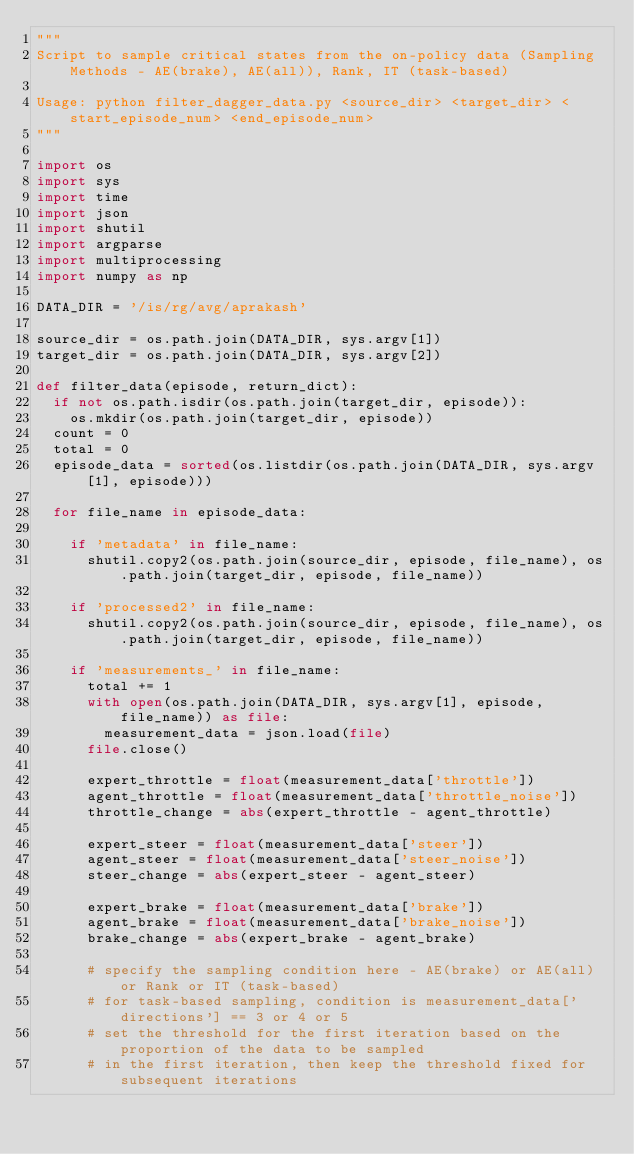<code> <loc_0><loc_0><loc_500><loc_500><_Python_>"""
Script to sample critical states from the on-policy data (Sampling Methods - AE(brake), AE(all)), Rank, IT (task-based)

Usage: python filter_dagger_data.py <source_dir> <target_dir> <start_episode_num> <end_episode_num>
"""

import os
import sys
import time
import json
import shutil
import argparse
import multiprocessing
import numpy as np

DATA_DIR = '/is/rg/avg/aprakash'

source_dir = os.path.join(DATA_DIR, sys.argv[1])
target_dir = os.path.join(DATA_DIR, sys.argv[2])

def filter_data(episode, return_dict):
	if not os.path.isdir(os.path.join(target_dir, episode)):
		os.mkdir(os.path.join(target_dir, episode))
	count = 0
	total = 0
	episode_data = sorted(os.listdir(os.path.join(DATA_DIR, sys.argv[1], episode)))
			
	for file_name in episode_data:
		
		if 'metadata' in file_name:
			shutil.copy2(os.path.join(source_dir, episode, file_name), os.path.join(target_dir, episode, file_name))

		if 'processed2' in file_name:
			shutil.copy2(os.path.join(source_dir, episode, file_name), os.path.join(target_dir, episode, file_name))
		
		if 'measurements_' in file_name:
			total += 1
			with open(os.path.join(DATA_DIR, sys.argv[1], episode, file_name)) as file:
				measurement_data = json.load(file)
			file.close()

			expert_throttle = float(measurement_data['throttle'])
			agent_throttle = float(measurement_data['throttle_noise'])
			throttle_change = abs(expert_throttle - agent_throttle)
			
			expert_steer = float(measurement_data['steer'])
			agent_steer = float(measurement_data['steer_noise'])
			steer_change = abs(expert_steer - agent_steer)

			expert_brake = float(measurement_data['brake'])
			agent_brake = float(measurement_data['brake_noise'])
			brake_change = abs(expert_brake - agent_brake)

			# specify the sampling condition here - AE(brake) or AE(all) or Rank or IT (task-based)
			# for task-based sampling, condition is measurement_data['directions'] == 3 or 4 or 5
			# set the threshold for the first iteration based on the proportion of the data to be sampled
			# in the first iteration, then keep the threshold fixed for subsequent iterations</code> 